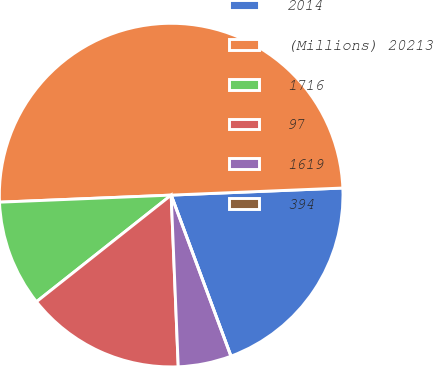Convert chart. <chart><loc_0><loc_0><loc_500><loc_500><pie_chart><fcel>2014<fcel>(Millions) 20213<fcel>1716<fcel>97<fcel>1619<fcel>394<nl><fcel>20.0%<fcel>50.0%<fcel>10.0%<fcel>15.0%<fcel>5.0%<fcel>0.0%<nl></chart> 